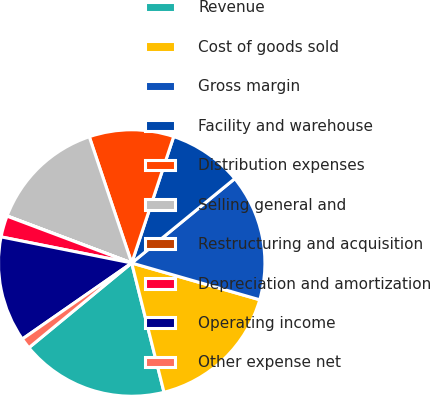Convert chart. <chart><loc_0><loc_0><loc_500><loc_500><pie_chart><fcel>Revenue<fcel>Cost of goods sold<fcel>Gross margin<fcel>Facility and warehouse<fcel>Distribution expenses<fcel>Selling general and<fcel>Restructuring and acquisition<fcel>Depreciation and amortization<fcel>Operating income<fcel>Other expense net<nl><fcel>17.93%<fcel>16.65%<fcel>15.37%<fcel>8.98%<fcel>10.26%<fcel>14.09%<fcel>0.03%<fcel>2.58%<fcel>12.81%<fcel>1.3%<nl></chart> 